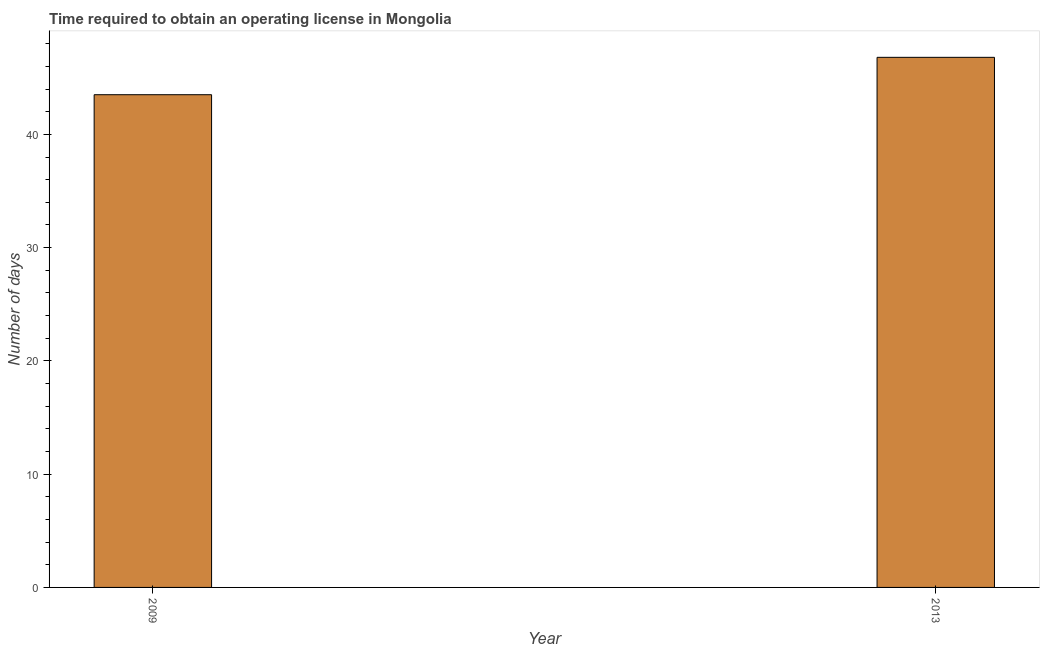Does the graph contain grids?
Your answer should be compact. No. What is the title of the graph?
Offer a very short reply. Time required to obtain an operating license in Mongolia. What is the label or title of the X-axis?
Offer a terse response. Year. What is the label or title of the Y-axis?
Your answer should be compact. Number of days. What is the number of days to obtain operating license in 2009?
Provide a succinct answer. 43.5. Across all years, what is the maximum number of days to obtain operating license?
Make the answer very short. 46.8. Across all years, what is the minimum number of days to obtain operating license?
Your response must be concise. 43.5. In which year was the number of days to obtain operating license maximum?
Your answer should be compact. 2013. In which year was the number of days to obtain operating license minimum?
Your answer should be compact. 2009. What is the sum of the number of days to obtain operating license?
Give a very brief answer. 90.3. What is the difference between the number of days to obtain operating license in 2009 and 2013?
Give a very brief answer. -3.3. What is the average number of days to obtain operating license per year?
Make the answer very short. 45.15. What is the median number of days to obtain operating license?
Offer a very short reply. 45.15. What is the ratio of the number of days to obtain operating license in 2009 to that in 2013?
Keep it short and to the point. 0.93. How many bars are there?
Offer a terse response. 2. Are all the bars in the graph horizontal?
Your answer should be very brief. No. Are the values on the major ticks of Y-axis written in scientific E-notation?
Provide a succinct answer. No. What is the Number of days of 2009?
Give a very brief answer. 43.5. What is the Number of days of 2013?
Offer a very short reply. 46.8. What is the ratio of the Number of days in 2009 to that in 2013?
Provide a succinct answer. 0.93. 